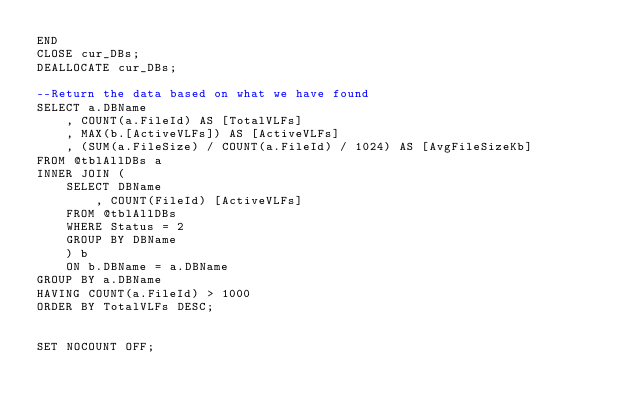<code> <loc_0><loc_0><loc_500><loc_500><_SQL_>END
CLOSE cur_DBs;
DEALLOCATE cur_DBs;

--Return the data based on what we have found
SELECT a.DBName
	, COUNT(a.FileId) AS [TotalVLFs]
	, MAX(b.[ActiveVLFs]) AS [ActiveVLFs]
	, (SUM(a.FileSize) / COUNT(a.FileId) / 1024) AS [AvgFileSizeKb]
FROM @tblAllDBs a
INNER JOIN (
	SELECT DBName
		, COUNT(FileId) [ActiveVLFs]
	FROM @tblAllDBs 
	WHERE Status = 2
	GROUP BY DBName
	) b
	ON b.DBName = a.DBName
GROUP BY a.DBName
HAVING COUNT(a.FileId) > 1000
ORDER BY TotalVLFs DESC;


SET NOCOUNT OFF;

</code> 